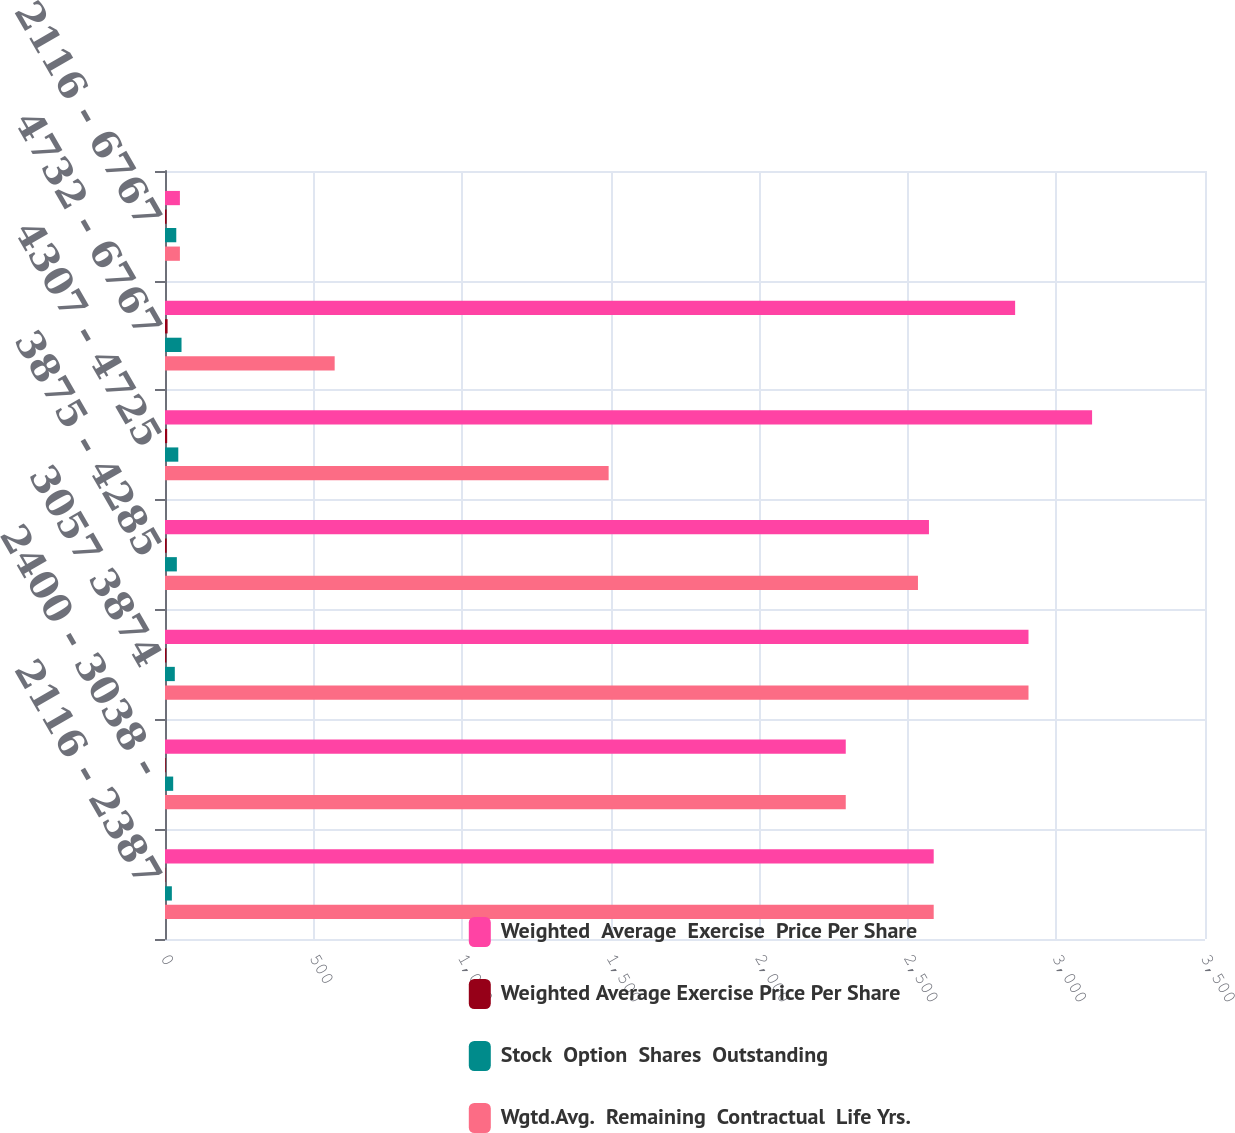Convert chart. <chart><loc_0><loc_0><loc_500><loc_500><stacked_bar_chart><ecel><fcel>2116 - 2387<fcel>2400 - 3038 -<fcel>3057 3874<fcel>3875 - 4285<fcel>4307 - 4725<fcel>4732 - 6767<fcel>2116 - 6767<nl><fcel>Weighted  Average  Exercise  Price Per Share<fcel>2587<fcel>2291<fcel>2906<fcel>2571<fcel>3120<fcel>2861<fcel>50.16<nl><fcel>Weighted Average Exercise Price Per Share<fcel>1.4<fcel>2.5<fcel>4.5<fcel>5.5<fcel>7.3<fcel>8.7<fcel>5.2<nl><fcel>Stock  Option  Shares  Outstanding<fcel>23.1<fcel>27.57<fcel>33.01<fcel>39.88<fcel>44.73<fcel>55.59<fcel>37.95<nl><fcel>Wgtd.Avg.  Remaining  Contractual  Life Yrs.<fcel>2587<fcel>2291<fcel>2906<fcel>2534<fcel>1493<fcel>571<fcel>50.16<nl></chart> 